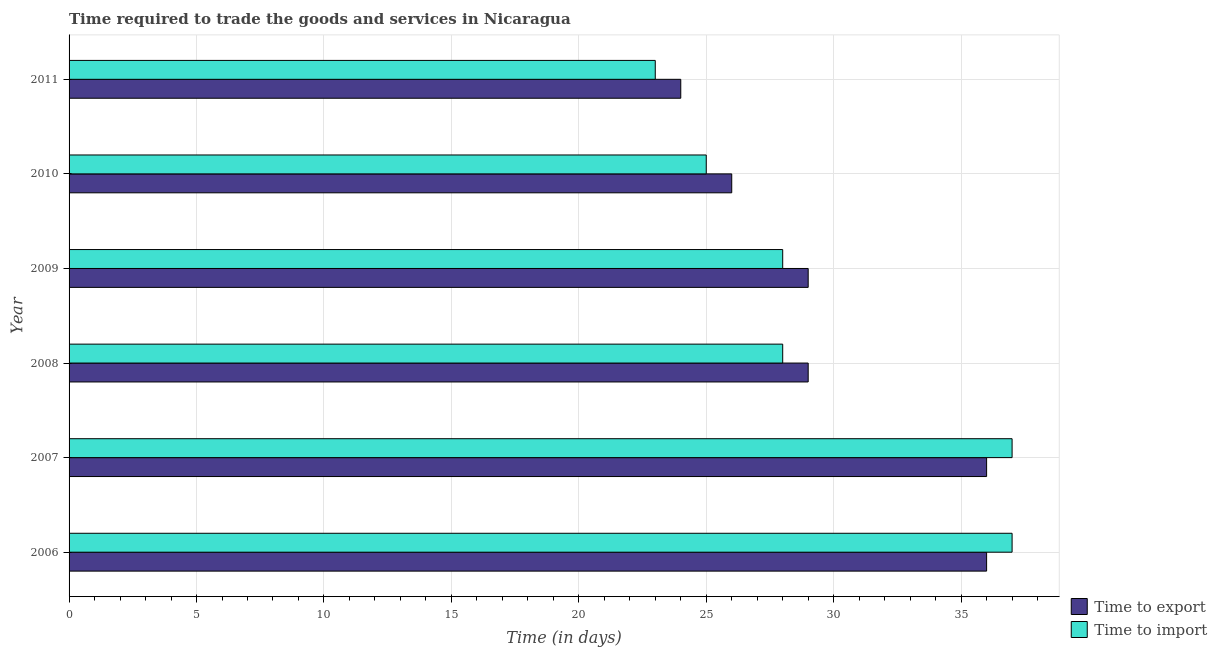How many groups of bars are there?
Your answer should be very brief. 6. Are the number of bars on each tick of the Y-axis equal?
Offer a terse response. Yes. What is the label of the 2nd group of bars from the top?
Offer a terse response. 2010. In how many cases, is the number of bars for a given year not equal to the number of legend labels?
Give a very brief answer. 0. What is the time to export in 2006?
Keep it short and to the point. 36. Across all years, what is the maximum time to import?
Your answer should be compact. 37. Across all years, what is the minimum time to export?
Provide a succinct answer. 24. What is the total time to export in the graph?
Your answer should be very brief. 180. What is the difference between the time to export in 2007 and that in 2009?
Keep it short and to the point. 7. What is the difference between the time to import in 2008 and the time to export in 2011?
Provide a short and direct response. 4. In the year 2006, what is the difference between the time to import and time to export?
Offer a very short reply. 1. In how many years, is the time to export greater than 6 days?
Give a very brief answer. 6. What is the ratio of the time to import in 2006 to that in 2007?
Give a very brief answer. 1. Is the time to export in 2007 less than that in 2008?
Your answer should be compact. No. What is the difference between the highest and the lowest time to export?
Provide a short and direct response. 12. In how many years, is the time to export greater than the average time to export taken over all years?
Ensure brevity in your answer.  2. What does the 2nd bar from the top in 2007 represents?
Offer a terse response. Time to export. What does the 1st bar from the bottom in 2007 represents?
Offer a very short reply. Time to export. How many bars are there?
Provide a short and direct response. 12. What is the difference between two consecutive major ticks on the X-axis?
Make the answer very short. 5. Does the graph contain grids?
Provide a short and direct response. Yes. Where does the legend appear in the graph?
Your answer should be very brief. Bottom right. What is the title of the graph?
Your answer should be very brief. Time required to trade the goods and services in Nicaragua. What is the label or title of the X-axis?
Provide a succinct answer. Time (in days). What is the label or title of the Y-axis?
Provide a short and direct response. Year. What is the Time (in days) in Time to import in 2006?
Ensure brevity in your answer.  37. What is the Time (in days) in Time to import in 2007?
Your response must be concise. 37. What is the Time (in days) of Time to export in 2008?
Offer a terse response. 29. What is the Time (in days) of Time to import in 2008?
Provide a succinct answer. 28. What is the Time (in days) of Time to import in 2009?
Provide a succinct answer. 28. What is the Time (in days) in Time to export in 2010?
Provide a short and direct response. 26. What is the Time (in days) in Time to import in 2010?
Offer a terse response. 25. Across all years, what is the minimum Time (in days) in Time to import?
Your answer should be compact. 23. What is the total Time (in days) in Time to export in the graph?
Keep it short and to the point. 180. What is the total Time (in days) of Time to import in the graph?
Your answer should be compact. 178. What is the difference between the Time (in days) in Time to export in 2006 and that in 2008?
Give a very brief answer. 7. What is the difference between the Time (in days) in Time to export in 2006 and that in 2009?
Your answer should be very brief. 7. What is the difference between the Time (in days) of Time to export in 2006 and that in 2010?
Your answer should be compact. 10. What is the difference between the Time (in days) in Time to export in 2006 and that in 2011?
Provide a succinct answer. 12. What is the difference between the Time (in days) of Time to import in 2006 and that in 2011?
Provide a short and direct response. 14. What is the difference between the Time (in days) of Time to export in 2007 and that in 2008?
Ensure brevity in your answer.  7. What is the difference between the Time (in days) of Time to import in 2007 and that in 2009?
Offer a terse response. 9. What is the difference between the Time (in days) of Time to import in 2007 and that in 2010?
Provide a short and direct response. 12. What is the difference between the Time (in days) in Time to import in 2007 and that in 2011?
Your answer should be compact. 14. What is the difference between the Time (in days) of Time to export in 2008 and that in 2010?
Make the answer very short. 3. What is the difference between the Time (in days) in Time to import in 2009 and that in 2010?
Provide a short and direct response. 3. What is the difference between the Time (in days) of Time to export in 2009 and that in 2011?
Ensure brevity in your answer.  5. What is the difference between the Time (in days) in Time to export in 2010 and that in 2011?
Provide a succinct answer. 2. What is the difference between the Time (in days) of Time to export in 2006 and the Time (in days) of Time to import in 2011?
Provide a short and direct response. 13. What is the difference between the Time (in days) of Time to export in 2007 and the Time (in days) of Time to import in 2008?
Make the answer very short. 8. What is the difference between the Time (in days) of Time to export in 2007 and the Time (in days) of Time to import in 2010?
Offer a very short reply. 11. What is the difference between the Time (in days) of Time to export in 2008 and the Time (in days) of Time to import in 2011?
Offer a terse response. 6. What is the difference between the Time (in days) in Time to export in 2009 and the Time (in days) in Time to import in 2011?
Give a very brief answer. 6. What is the average Time (in days) in Time to import per year?
Give a very brief answer. 29.67. In the year 2010, what is the difference between the Time (in days) in Time to export and Time (in days) in Time to import?
Make the answer very short. 1. What is the ratio of the Time (in days) of Time to export in 2006 to that in 2007?
Offer a terse response. 1. What is the ratio of the Time (in days) in Time to export in 2006 to that in 2008?
Provide a short and direct response. 1.24. What is the ratio of the Time (in days) in Time to import in 2006 to that in 2008?
Make the answer very short. 1.32. What is the ratio of the Time (in days) of Time to export in 2006 to that in 2009?
Provide a short and direct response. 1.24. What is the ratio of the Time (in days) in Time to import in 2006 to that in 2009?
Provide a short and direct response. 1.32. What is the ratio of the Time (in days) of Time to export in 2006 to that in 2010?
Keep it short and to the point. 1.38. What is the ratio of the Time (in days) in Time to import in 2006 to that in 2010?
Your answer should be very brief. 1.48. What is the ratio of the Time (in days) of Time to export in 2006 to that in 2011?
Your answer should be compact. 1.5. What is the ratio of the Time (in days) of Time to import in 2006 to that in 2011?
Your answer should be compact. 1.61. What is the ratio of the Time (in days) of Time to export in 2007 to that in 2008?
Your answer should be very brief. 1.24. What is the ratio of the Time (in days) of Time to import in 2007 to that in 2008?
Make the answer very short. 1.32. What is the ratio of the Time (in days) in Time to export in 2007 to that in 2009?
Offer a very short reply. 1.24. What is the ratio of the Time (in days) in Time to import in 2007 to that in 2009?
Make the answer very short. 1.32. What is the ratio of the Time (in days) of Time to export in 2007 to that in 2010?
Your response must be concise. 1.38. What is the ratio of the Time (in days) of Time to import in 2007 to that in 2010?
Keep it short and to the point. 1.48. What is the ratio of the Time (in days) of Time to import in 2007 to that in 2011?
Offer a terse response. 1.61. What is the ratio of the Time (in days) in Time to import in 2008 to that in 2009?
Your response must be concise. 1. What is the ratio of the Time (in days) in Time to export in 2008 to that in 2010?
Your answer should be compact. 1.12. What is the ratio of the Time (in days) of Time to import in 2008 to that in 2010?
Your answer should be very brief. 1.12. What is the ratio of the Time (in days) of Time to export in 2008 to that in 2011?
Provide a succinct answer. 1.21. What is the ratio of the Time (in days) of Time to import in 2008 to that in 2011?
Your response must be concise. 1.22. What is the ratio of the Time (in days) in Time to export in 2009 to that in 2010?
Provide a short and direct response. 1.12. What is the ratio of the Time (in days) of Time to import in 2009 to that in 2010?
Keep it short and to the point. 1.12. What is the ratio of the Time (in days) of Time to export in 2009 to that in 2011?
Provide a succinct answer. 1.21. What is the ratio of the Time (in days) of Time to import in 2009 to that in 2011?
Your response must be concise. 1.22. What is the ratio of the Time (in days) of Time to import in 2010 to that in 2011?
Offer a very short reply. 1.09. What is the difference between the highest and the second highest Time (in days) of Time to export?
Ensure brevity in your answer.  0. What is the difference between the highest and the lowest Time (in days) of Time to export?
Ensure brevity in your answer.  12. 